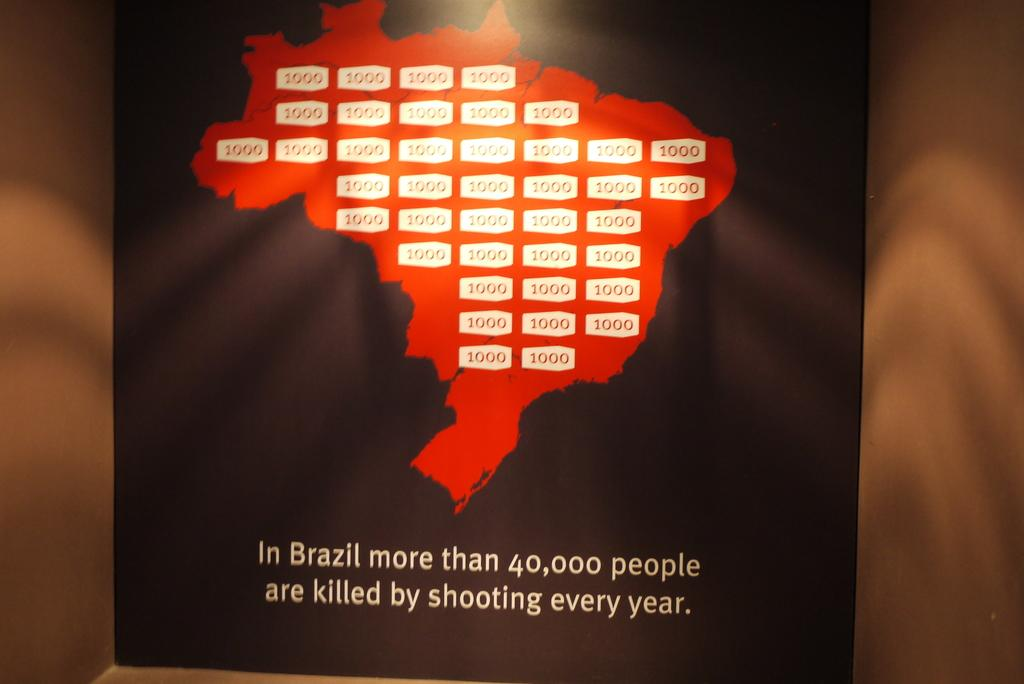Provide a one-sentence caption for the provided image. A poster for shooting violence in Brazil states that 40,000 people are killed in shootings every year. 